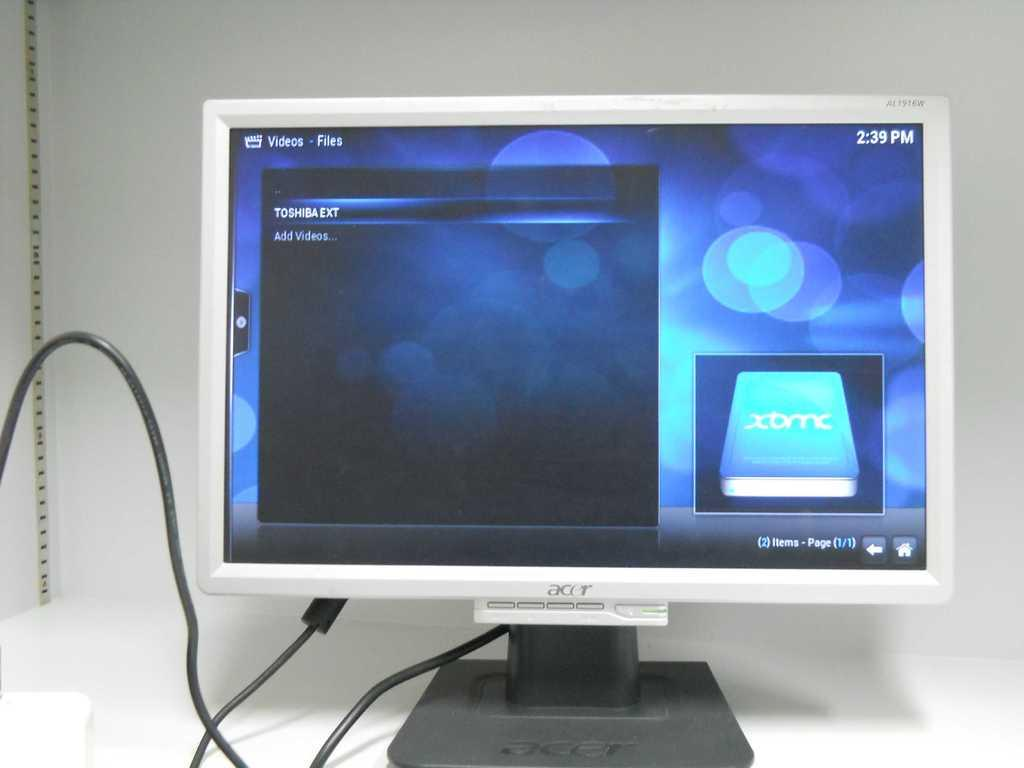<image>
Offer a succinct explanation of the picture presented. An acer monitor is displaying the files of a Toshiba EXT 